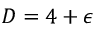Convert formula to latex. <formula><loc_0><loc_0><loc_500><loc_500>D = 4 + \epsilon</formula> 